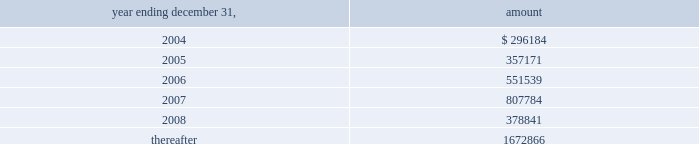Vornado realty trust72 ( 6 ) on june 21 , 2002 , one of the lenders purchased the other participant 2019s interest in the loan .
At the same time , the loan was extended for one year , with certain modifications , including ( i ) making the risk of a loss due to terrorism ( as defined ) not covered by insurance recourse to the company and ( ii ) the granting of two 1-year renewal options to the company .
( 7 ) on november 25 , 2003 , the company completed an offering of $ 200000 , aggregate principal amount of 4.75% ( 4.75 % ) senior unsecured notes due december 1 , 2010 .
Interest on the notes is payable semi-annually on june 1st and december 1st , commencing in 2004 .
The notes were priced at 99.869% ( 99.869 % ) of their face amount to yield 4.772% ( 4.772 % ) .
The notes contain the same financial covenants that are in the company 2019s notes issued in june 2002 , except the maximum ratio of secured debt to total assets is now 50% ( 50 % ) ( previously 55% ( 55 % ) ) .
The net proceeds of approximately $ 198500 were used primarily to repay existing mortgage debt .
( 8 ) on july 3 , 2003 , the company entered into a new $ 600000 unsecured revolving credit facility which has replaced its $ 1 billion unsecured revolving credit facility which was to mature in july 2003 .
The new facility has a three-year term , a one-year extension option and bears interest at libor plus .65% ( .65 % ) .
The company also has the ability under the new facility to seek up to $ 800000 of commitments during the facility 2019s term .
The new facility contains financial covenants similar to the prior facility .
The net carrying amount of properties collateralizing the notes and mortgages amounted to $ 4557065000 at december 31 , 2003 .
As at december 31 , 2003 , the principal repayments required for the next five years and thereafter are as follows : ( amounts in thousands ) .
Shareholders 2019 equity common shares of beneficial interest on february 25 , 2002 , the company sold 1398743 common shares based on the closing price of $ 42.96 on the nyse .
The net proceeds to the company were approximately $ 56453000 .
Series a preferred shares of beneficial interest holders of series a preferred shares of beneficial interest are entitled to receive dividends in an amount equivalent to $ 3.25 per annum per share .
These dividends are cumulative and payable quarterly in arrears .
The series a preferred shares are convertible at any time at the option of their respective holders at a conversion rate of 1.38504 common shares per series a preferred share , subject to adjustment in certain circumstances .
In addition , upon the satisfaction of certain conditions the company , at its option , may redeem the $ 3.25 series a preferred shares at a current conversion rate of 1.38504 common shares per series a preferred share , subject to adjustment in certain circumstances .
At no time will the series a preferred shares be redeemable for cash .
Series b preferred shares of beneficial interest holders of series b preferred shares of beneficial interest are entitled to receive dividends at an annual rate of 8.5% ( 8.5 % ) of the liquidation preference , or $ 2.125 per series b preferred share per annum .
These dividends are cumulative and payable quarterly in arrears .
The series b preferred shares are not convertible into or exchangeable for any other property or any other securities of the company at the election of the holders .
However , subject to certain limitations relating to the source of funds used in connection with any such redemption , on or after march 17 , 2004 ( or sooner under limited circumstances ) , the company , at its option , may redeem series b preferred shares at a redemption price of $ 25.00 per share , plus any accrued and unpaid dividends through the date of redemption .
The series b preferred shares have no maturity date and will remain outstanding indefinitely unless redeemed by the company .
On february 17 , 2004 , the company has called for the redemption of all of the outstanding series b preferred shares .
The shares will be redeemed on march 17 , 2004 at the redemption price of $ 25.00 per share , aggregating $ 85000000 plus accrued dividends .
The redemption amount exceeds the carrying amount by $ 2100000 , representing original issuance costs .
Notes to consolidated financial statements sr-176_fin_l02p53_82v1.qxd 4/8/04 2:17 pm page 72 .
What was the change in principal payments due in 2006 versus 2007 in thousands? 
Computations: (551539 - 807784)
Answer: -256245.0. Vornado realty trust72 ( 6 ) on june 21 , 2002 , one of the lenders purchased the other participant 2019s interest in the loan .
At the same time , the loan was extended for one year , with certain modifications , including ( i ) making the risk of a loss due to terrorism ( as defined ) not covered by insurance recourse to the company and ( ii ) the granting of two 1-year renewal options to the company .
( 7 ) on november 25 , 2003 , the company completed an offering of $ 200000 , aggregate principal amount of 4.75% ( 4.75 % ) senior unsecured notes due december 1 , 2010 .
Interest on the notes is payable semi-annually on june 1st and december 1st , commencing in 2004 .
The notes were priced at 99.869% ( 99.869 % ) of their face amount to yield 4.772% ( 4.772 % ) .
The notes contain the same financial covenants that are in the company 2019s notes issued in june 2002 , except the maximum ratio of secured debt to total assets is now 50% ( 50 % ) ( previously 55% ( 55 % ) ) .
The net proceeds of approximately $ 198500 were used primarily to repay existing mortgage debt .
( 8 ) on july 3 , 2003 , the company entered into a new $ 600000 unsecured revolving credit facility which has replaced its $ 1 billion unsecured revolving credit facility which was to mature in july 2003 .
The new facility has a three-year term , a one-year extension option and bears interest at libor plus .65% ( .65 % ) .
The company also has the ability under the new facility to seek up to $ 800000 of commitments during the facility 2019s term .
The new facility contains financial covenants similar to the prior facility .
The net carrying amount of properties collateralizing the notes and mortgages amounted to $ 4557065000 at december 31 , 2003 .
As at december 31 , 2003 , the principal repayments required for the next five years and thereafter are as follows : ( amounts in thousands ) .
Shareholders 2019 equity common shares of beneficial interest on february 25 , 2002 , the company sold 1398743 common shares based on the closing price of $ 42.96 on the nyse .
The net proceeds to the company were approximately $ 56453000 .
Series a preferred shares of beneficial interest holders of series a preferred shares of beneficial interest are entitled to receive dividends in an amount equivalent to $ 3.25 per annum per share .
These dividends are cumulative and payable quarterly in arrears .
The series a preferred shares are convertible at any time at the option of their respective holders at a conversion rate of 1.38504 common shares per series a preferred share , subject to adjustment in certain circumstances .
In addition , upon the satisfaction of certain conditions the company , at its option , may redeem the $ 3.25 series a preferred shares at a current conversion rate of 1.38504 common shares per series a preferred share , subject to adjustment in certain circumstances .
At no time will the series a preferred shares be redeemable for cash .
Series b preferred shares of beneficial interest holders of series b preferred shares of beneficial interest are entitled to receive dividends at an annual rate of 8.5% ( 8.5 % ) of the liquidation preference , or $ 2.125 per series b preferred share per annum .
These dividends are cumulative and payable quarterly in arrears .
The series b preferred shares are not convertible into or exchangeable for any other property or any other securities of the company at the election of the holders .
However , subject to certain limitations relating to the source of funds used in connection with any such redemption , on or after march 17 , 2004 ( or sooner under limited circumstances ) , the company , at its option , may redeem series b preferred shares at a redemption price of $ 25.00 per share , plus any accrued and unpaid dividends through the date of redemption .
The series b preferred shares have no maturity date and will remain outstanding indefinitely unless redeemed by the company .
On february 17 , 2004 , the company has called for the redemption of all of the outstanding series b preferred shares .
The shares will be redeemed on march 17 , 2004 at the redemption price of $ 25.00 per share , aggregating $ 85000000 plus accrued dividends .
The redemption amount exceeds the carrying amount by $ 2100000 , representing original issuance costs .
Notes to consolidated financial statements sr-176_fin_l02p53_82v1.qxd 4/8/04 2:17 pm page 72 .
As of 2013 , principal payments required in 2008 were what percent of those due after 5 years? 
Computations: (378841 / 1672866)
Answer: 0.22646. 